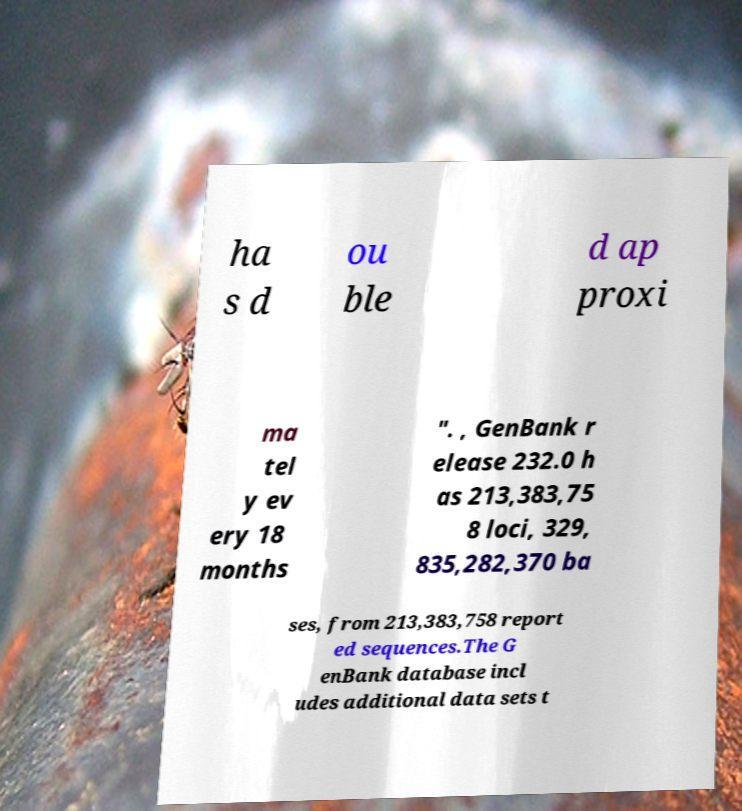Please identify and transcribe the text found in this image. ha s d ou ble d ap proxi ma tel y ev ery 18 months ". , GenBank r elease 232.0 h as 213,383,75 8 loci, 329, 835,282,370 ba ses, from 213,383,758 report ed sequences.The G enBank database incl udes additional data sets t 